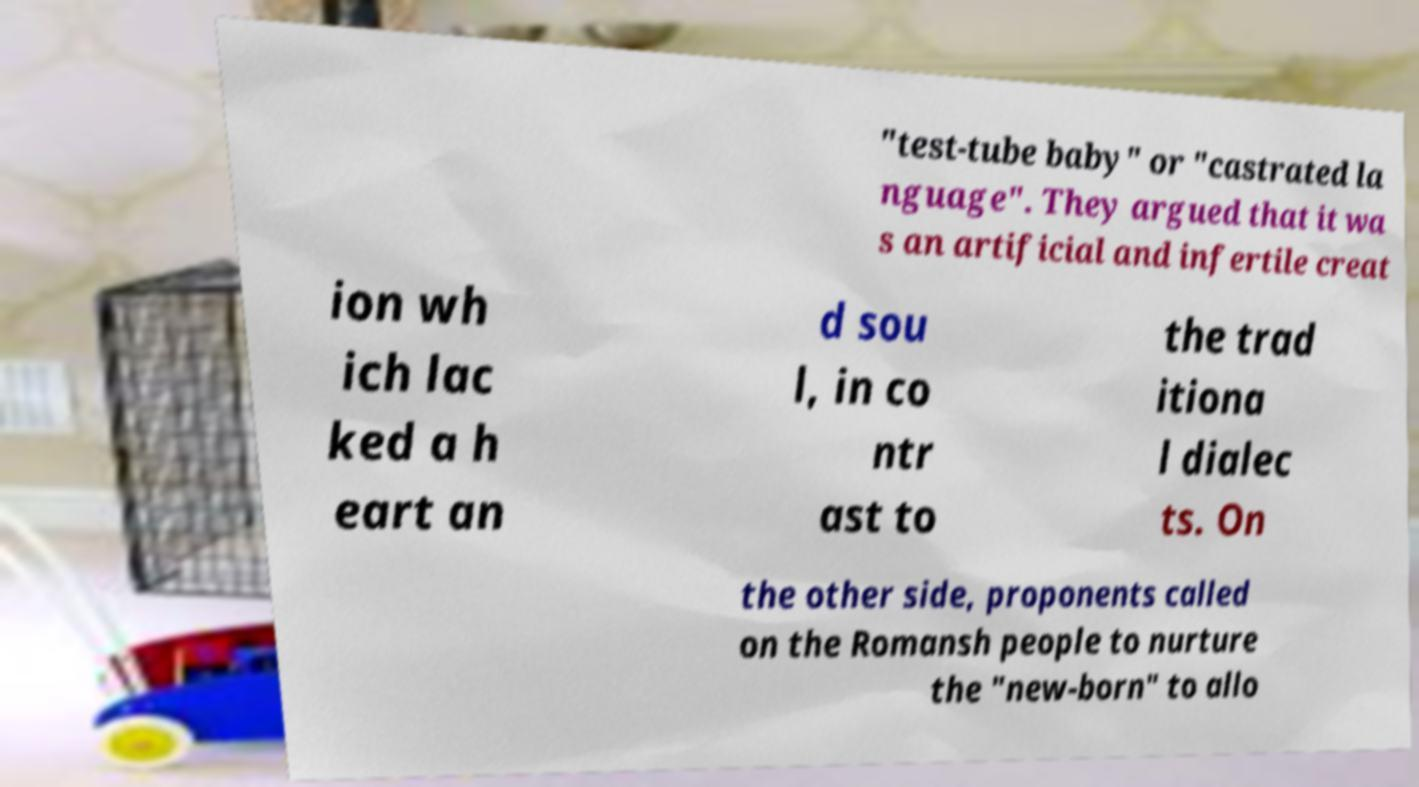What messages or text are displayed in this image? I need them in a readable, typed format. "test-tube baby" or "castrated la nguage". They argued that it wa s an artificial and infertile creat ion wh ich lac ked a h eart an d sou l, in co ntr ast to the trad itiona l dialec ts. On the other side, proponents called on the Romansh people to nurture the "new-born" to allo 